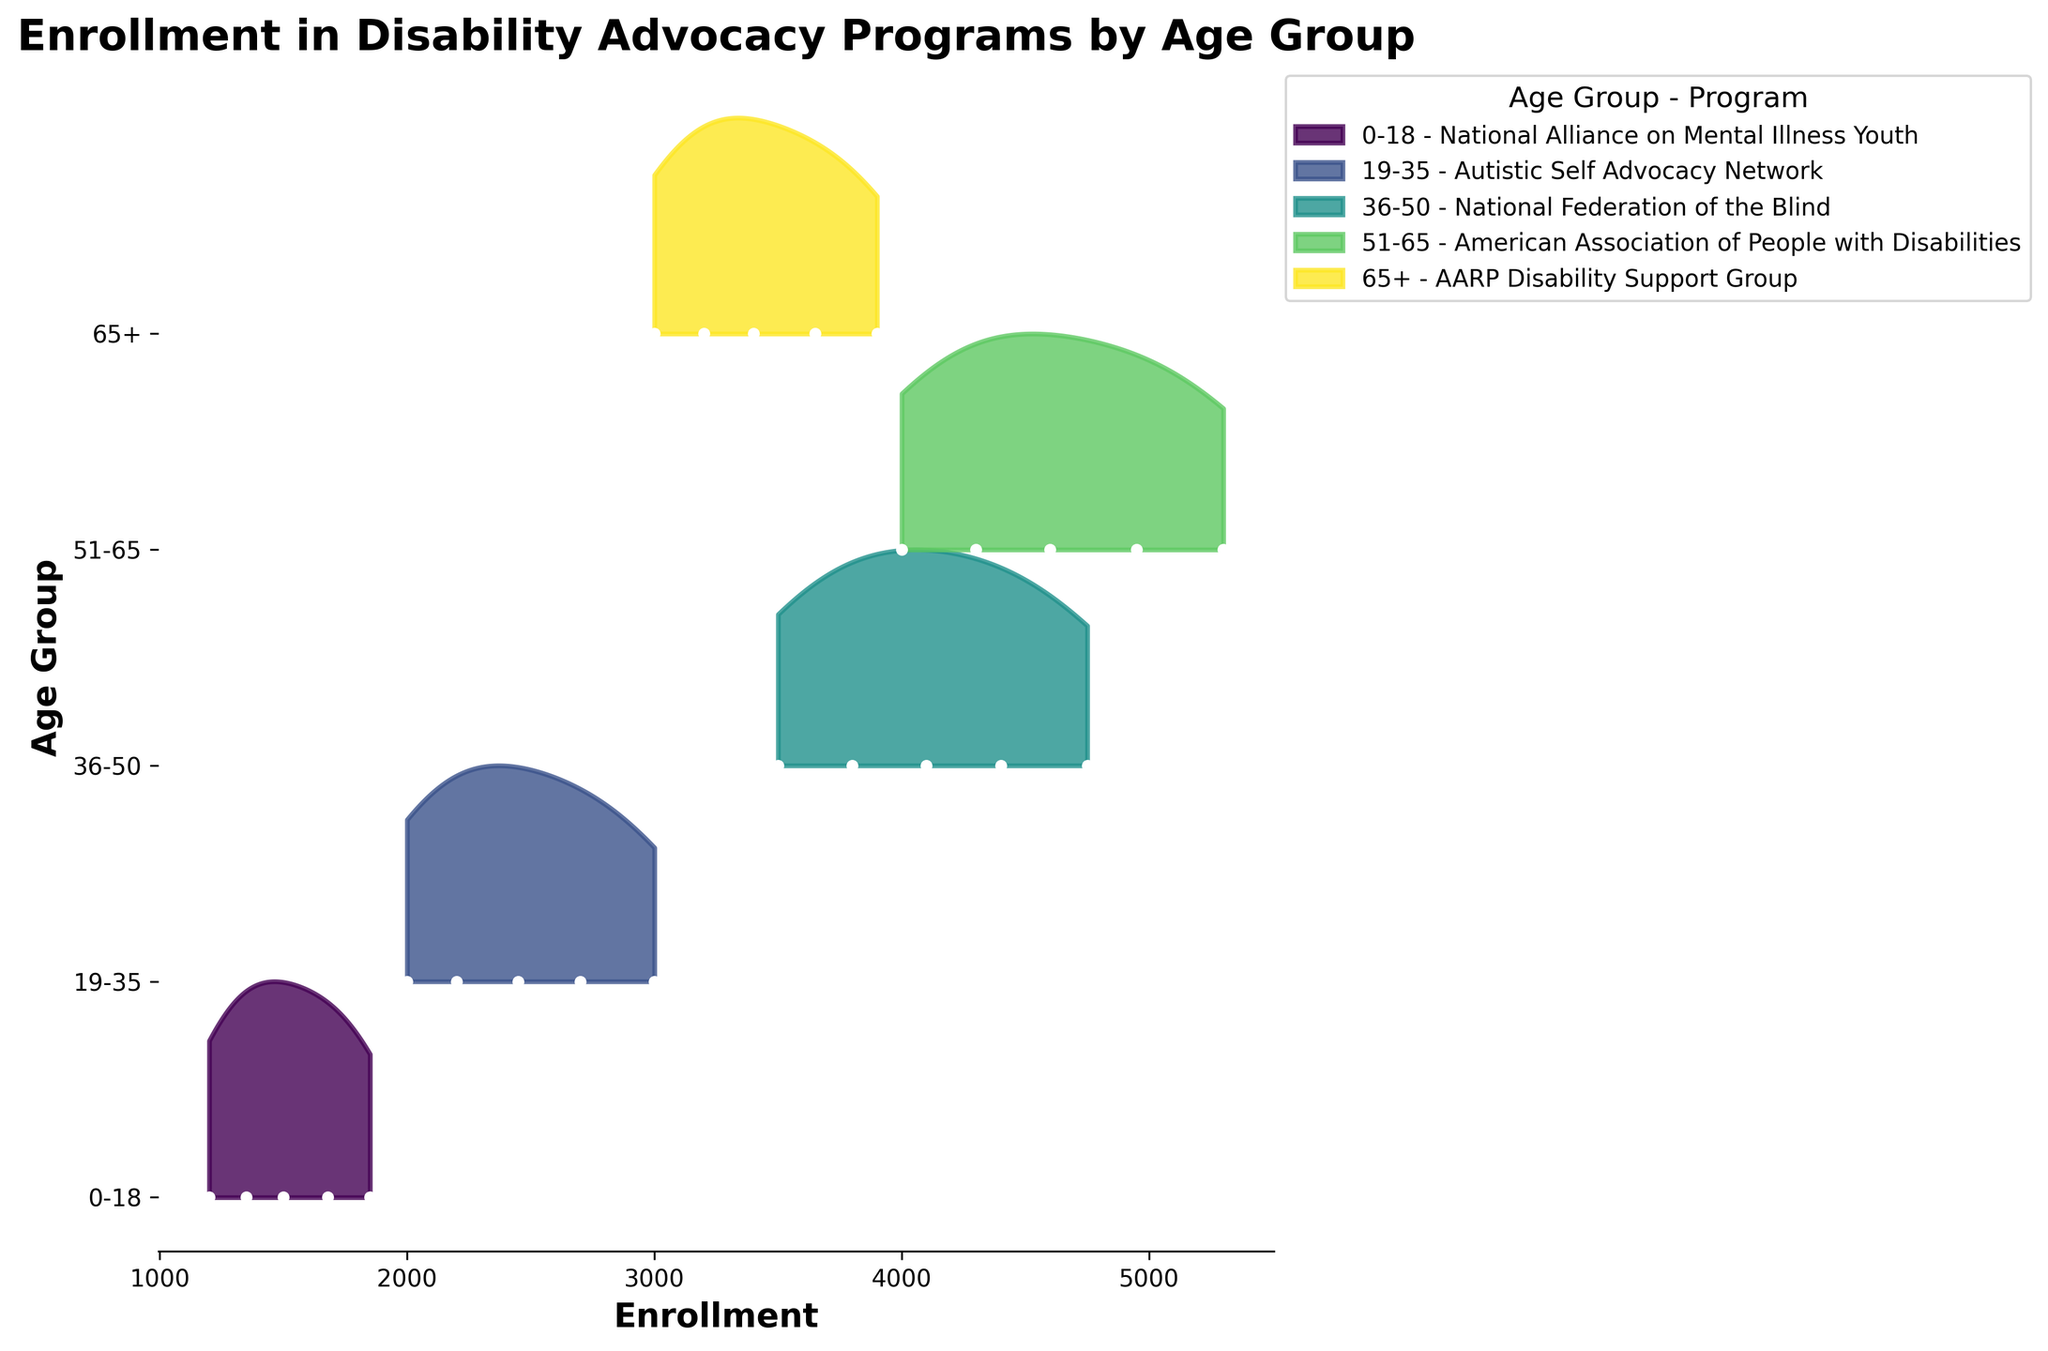what is the title of the figure? The title is usually displayed at the top of a figure in a large and bold font. By looking at the top of the figure, we can read the title.
Answer: Enrollment in Disability Advocacy Programs by Age Group Which age group has the highest enrollment in 2019? By examining the rightmost data point (year 2019) for each ridgeline corresponding to different age groups, we can identify the highest enrollment value. The 51-65 age group shows the peak enrollment.
Answer: 51-65 Is there an age group that shows a declining or flat trend over the years? All the age groups show an increasing enrollment trend by visual observation of the positions of data points from 2015 to 2019 across all ridgelines. None show a decline or flat trend.
Answer: No What program does the 36-50 age group correspond to? The legend at the right side of the figure lists age groups and their corresponding programs. By locating the "36-50" age group, we can find the associated program.
Answer: National Federation of the Blind Which age group shows the smoothest increase in enrollment over the years? By examining the data points' intervals and overall trend smoothness (minimal fluctuations) through the ridgelines, the 36-50 group exhibits the smoothest, most consistent upward trend.
Answer: 36-50 Which age group has the least visually prominent ridgeline color at the bottom? The color used in the ridgeline plot for each age group can be distinguished by its shading intensity. The "65+" shows a lighter, less intensive color at the bottom.
Answer: 65+ How do enrollment trends of the 19-35 and 0-18 age groups compare? By visually comparing the enrollment changes over the years for both age groups' ridgelines, it is observed that both increase, but 19-35 has a steeper increase compared to 0-18.
Answer: 19-35 increases more steeply In what year did the 0-18 age group see the largest increase in enrollment? By inspecting the gaps between consecutive data points, the largest gap for the 0-18 age group is between the years 2017 and 2018.
Answer: 2017-2018 For the 51-65 age group, what's the average enrollment from 2015 to 2019? To find the average enrollment, sum the enrollment values from 2015 to 2019 and divide by the number of years: (4000 + 4300 + 4600 + 4950 + 5300) / 5 = 23150 / 5 = 4630.
Answer: 4630 Which age group has the widest range of enrollment values? By assessing the range between the minimum and maximum enrollment values depicted along the y-axis for each age group's ridgeline, the widest range is observed in the 51-65 age group.
Answer: 51-65 